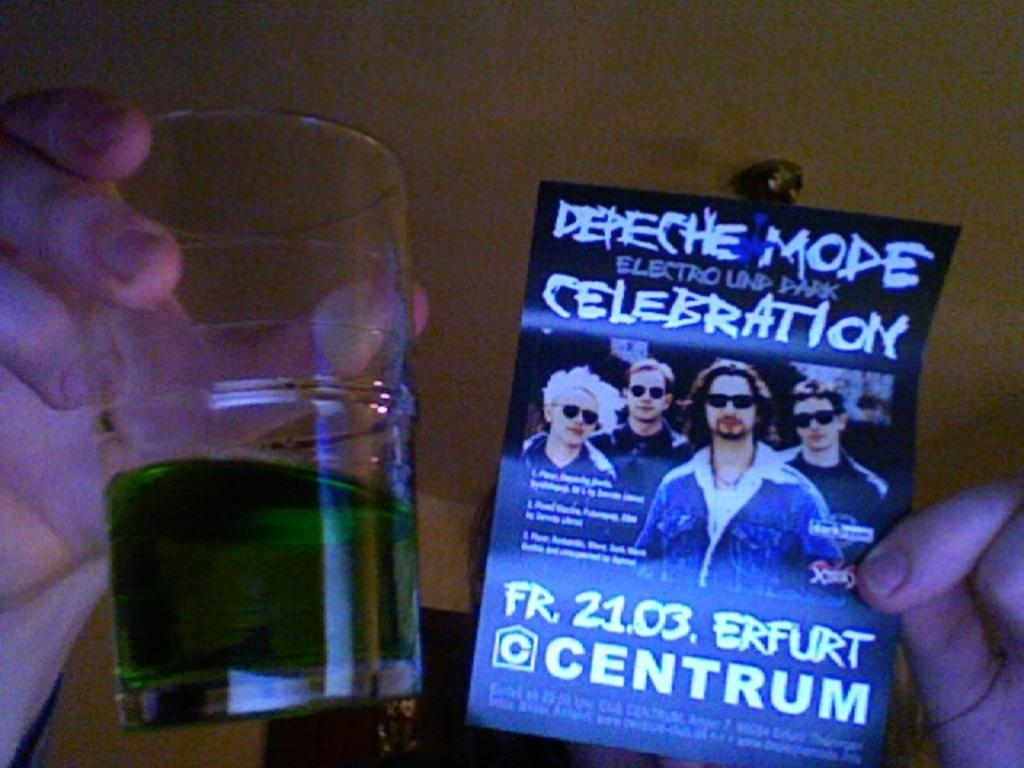What is the main subject of the image? There is a person in the image. What is the person holding in their hand? The person is holding a glass with liquid in it and a poster in their other hand. What can be seen in the background of the image? There is an object on the ceiling and a wall visible in the background of the image. What type of alley can be seen behind the person in the image? There is no alley visible in the image; it only shows a person holding a glass and a poster, as well as a ceiling object and a wall in the background. 